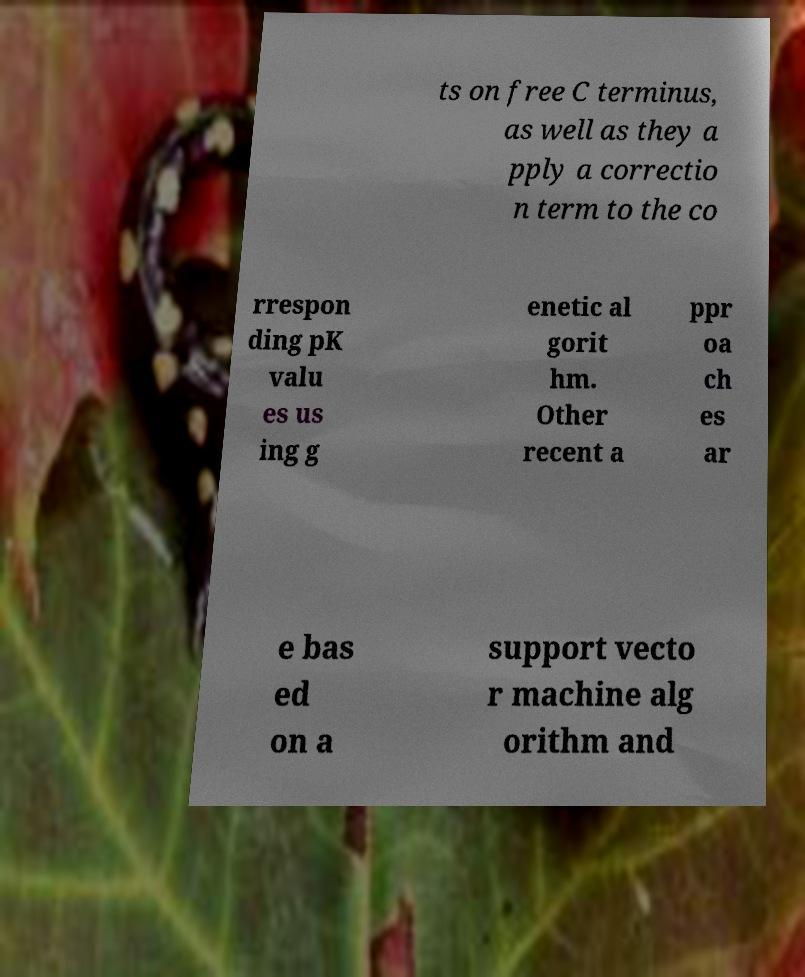Please read and relay the text visible in this image. What does it say? ts on free C terminus, as well as they a pply a correctio n term to the co rrespon ding pK valu es us ing g enetic al gorit hm. Other recent a ppr oa ch es ar e bas ed on a support vecto r machine alg orithm and 